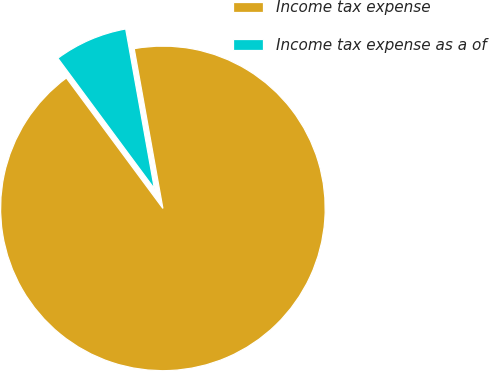<chart> <loc_0><loc_0><loc_500><loc_500><pie_chart><fcel>Income tax expense<fcel>Income tax expense as a of<nl><fcel>92.69%<fcel>7.31%<nl></chart> 